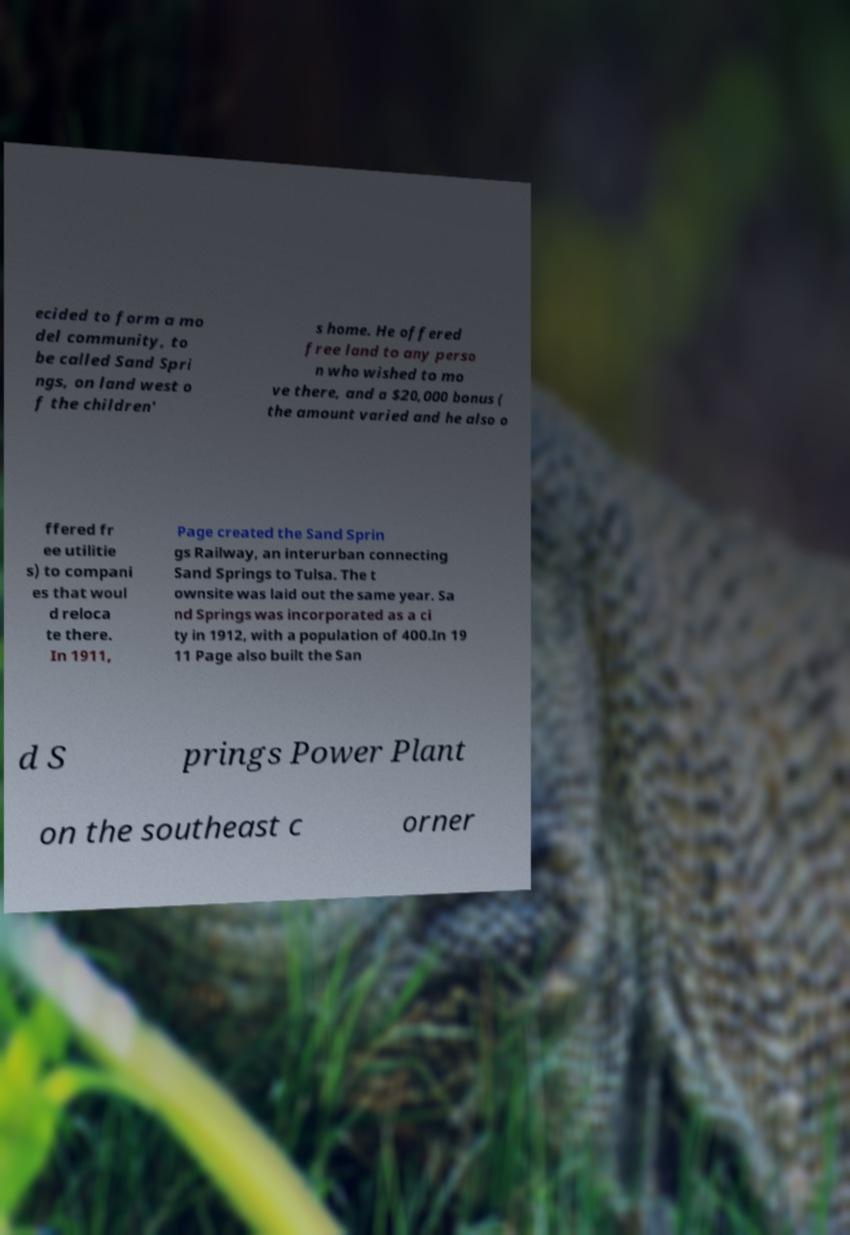Can you read and provide the text displayed in the image?This photo seems to have some interesting text. Can you extract and type it out for me? ecided to form a mo del community, to be called Sand Spri ngs, on land west o f the children' s home. He offered free land to any perso n who wished to mo ve there, and a $20,000 bonus ( the amount varied and he also o ffered fr ee utilitie s) to compani es that woul d reloca te there. In 1911, Page created the Sand Sprin gs Railway, an interurban connecting Sand Springs to Tulsa. The t ownsite was laid out the same year. Sa nd Springs was incorporated as a ci ty in 1912, with a population of 400.In 19 11 Page also built the San d S prings Power Plant on the southeast c orner 